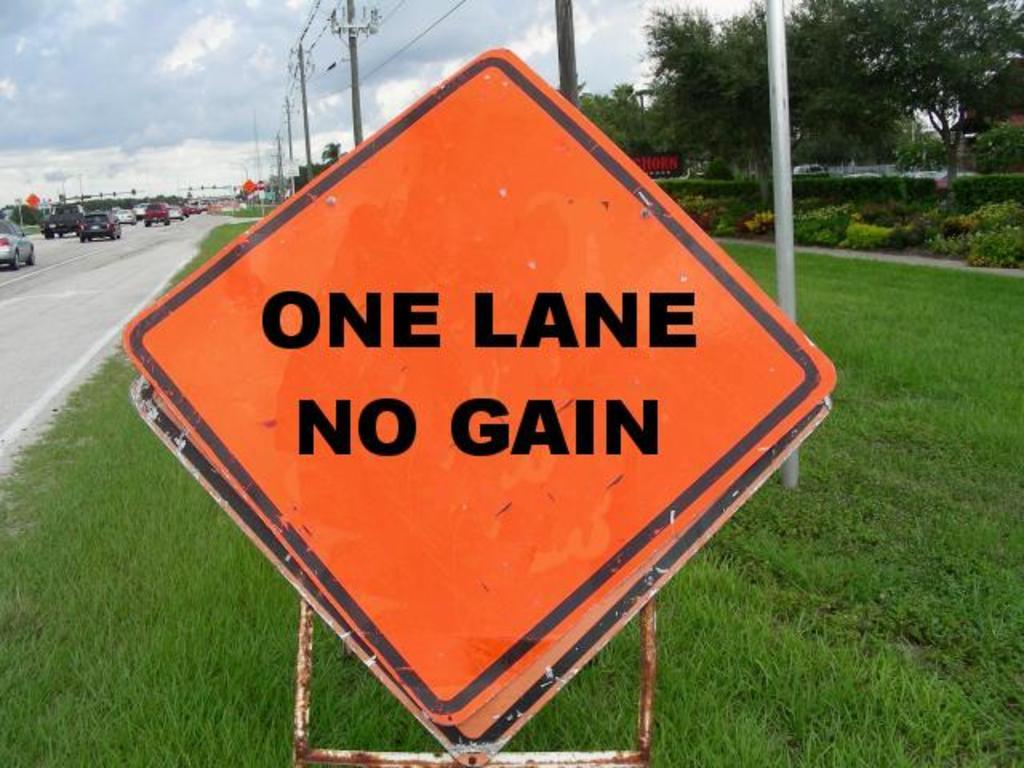<image>
Give a short and clear explanation of the subsequent image. Sign on the side of a street saying One Lane No Gain. 